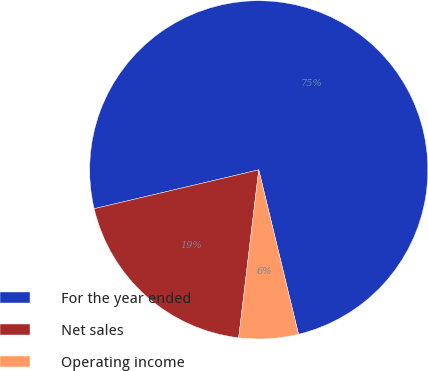Convert chart. <chart><loc_0><loc_0><loc_500><loc_500><pie_chart><fcel>For the year ended<fcel>Net sales<fcel>Operating income<nl><fcel>74.92%<fcel>19.42%<fcel>5.67%<nl></chart> 